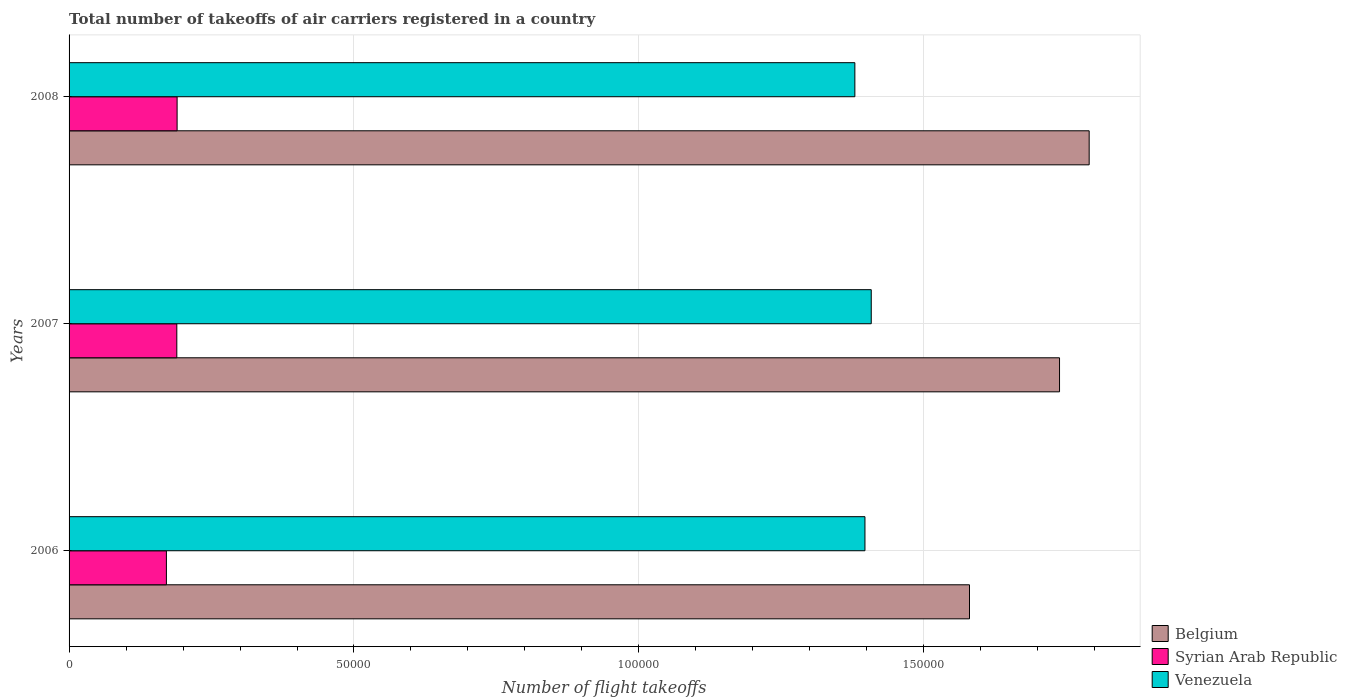How many different coloured bars are there?
Make the answer very short. 3. How many groups of bars are there?
Your answer should be compact. 3. Are the number of bars on each tick of the Y-axis equal?
Provide a succinct answer. Yes. What is the total number of flight takeoffs in Venezuela in 2006?
Offer a terse response. 1.40e+05. Across all years, what is the maximum total number of flight takeoffs in Belgium?
Your response must be concise. 1.79e+05. Across all years, what is the minimum total number of flight takeoffs in Syrian Arab Republic?
Ensure brevity in your answer.  1.71e+04. In which year was the total number of flight takeoffs in Belgium maximum?
Your answer should be very brief. 2008. In which year was the total number of flight takeoffs in Belgium minimum?
Make the answer very short. 2006. What is the total total number of flight takeoffs in Syrian Arab Republic in the graph?
Your answer should be compact. 5.50e+04. What is the difference between the total number of flight takeoffs in Venezuela in 2006 and that in 2008?
Your answer should be very brief. 1771. What is the difference between the total number of flight takeoffs in Belgium in 2006 and the total number of flight takeoffs in Syrian Arab Republic in 2007?
Give a very brief answer. 1.39e+05. What is the average total number of flight takeoffs in Syrian Arab Republic per year?
Give a very brief answer. 1.83e+04. In the year 2006, what is the difference between the total number of flight takeoffs in Belgium and total number of flight takeoffs in Venezuela?
Give a very brief answer. 1.83e+04. In how many years, is the total number of flight takeoffs in Belgium greater than 50000 ?
Offer a terse response. 3. What is the ratio of the total number of flight takeoffs in Syrian Arab Republic in 2007 to that in 2008?
Your answer should be compact. 1. Is the total number of flight takeoffs in Venezuela in 2006 less than that in 2008?
Provide a short and direct response. No. Is the difference between the total number of flight takeoffs in Belgium in 2007 and 2008 greater than the difference between the total number of flight takeoffs in Venezuela in 2007 and 2008?
Ensure brevity in your answer.  No. What is the difference between the highest and the lowest total number of flight takeoffs in Belgium?
Keep it short and to the point. 2.10e+04. In how many years, is the total number of flight takeoffs in Belgium greater than the average total number of flight takeoffs in Belgium taken over all years?
Offer a very short reply. 2. Is the sum of the total number of flight takeoffs in Syrian Arab Republic in 2006 and 2007 greater than the maximum total number of flight takeoffs in Belgium across all years?
Make the answer very short. No. What does the 1st bar from the top in 2006 represents?
Provide a short and direct response. Venezuela. What does the 3rd bar from the bottom in 2007 represents?
Keep it short and to the point. Venezuela. How many bars are there?
Your answer should be very brief. 9. Are all the bars in the graph horizontal?
Provide a short and direct response. Yes. How many years are there in the graph?
Your answer should be very brief. 3. What is the difference between two consecutive major ticks on the X-axis?
Keep it short and to the point. 5.00e+04. Does the graph contain any zero values?
Ensure brevity in your answer.  No. Where does the legend appear in the graph?
Your response must be concise. Bottom right. How many legend labels are there?
Your answer should be very brief. 3. How are the legend labels stacked?
Your answer should be very brief. Vertical. What is the title of the graph?
Your response must be concise. Total number of takeoffs of air carriers registered in a country. Does "Maldives" appear as one of the legend labels in the graph?
Offer a terse response. No. What is the label or title of the X-axis?
Offer a very short reply. Number of flight takeoffs. What is the label or title of the Y-axis?
Make the answer very short. Years. What is the Number of flight takeoffs in Belgium in 2006?
Provide a succinct answer. 1.58e+05. What is the Number of flight takeoffs of Syrian Arab Republic in 2006?
Your answer should be very brief. 1.71e+04. What is the Number of flight takeoffs of Venezuela in 2006?
Your response must be concise. 1.40e+05. What is the Number of flight takeoffs in Belgium in 2007?
Your response must be concise. 1.74e+05. What is the Number of flight takeoffs in Syrian Arab Republic in 2007?
Provide a succinct answer. 1.89e+04. What is the Number of flight takeoffs of Venezuela in 2007?
Keep it short and to the point. 1.41e+05. What is the Number of flight takeoffs in Belgium in 2008?
Keep it short and to the point. 1.79e+05. What is the Number of flight takeoffs in Syrian Arab Republic in 2008?
Make the answer very short. 1.90e+04. What is the Number of flight takeoffs of Venezuela in 2008?
Make the answer very short. 1.38e+05. Across all years, what is the maximum Number of flight takeoffs of Belgium?
Offer a terse response. 1.79e+05. Across all years, what is the maximum Number of flight takeoffs in Syrian Arab Republic?
Offer a terse response. 1.90e+04. Across all years, what is the maximum Number of flight takeoffs in Venezuela?
Your response must be concise. 1.41e+05. Across all years, what is the minimum Number of flight takeoffs in Belgium?
Your answer should be compact. 1.58e+05. Across all years, what is the minimum Number of flight takeoffs in Syrian Arab Republic?
Your answer should be compact. 1.71e+04. Across all years, what is the minimum Number of flight takeoffs in Venezuela?
Give a very brief answer. 1.38e+05. What is the total Number of flight takeoffs of Belgium in the graph?
Provide a succinct answer. 5.11e+05. What is the total Number of flight takeoffs in Syrian Arab Republic in the graph?
Your answer should be very brief. 5.50e+04. What is the total Number of flight takeoffs in Venezuela in the graph?
Ensure brevity in your answer.  4.18e+05. What is the difference between the Number of flight takeoffs in Belgium in 2006 and that in 2007?
Your answer should be compact. -1.58e+04. What is the difference between the Number of flight takeoffs of Syrian Arab Republic in 2006 and that in 2007?
Make the answer very short. -1827. What is the difference between the Number of flight takeoffs in Venezuela in 2006 and that in 2007?
Make the answer very short. -1103. What is the difference between the Number of flight takeoffs in Belgium in 2006 and that in 2008?
Ensure brevity in your answer.  -2.10e+04. What is the difference between the Number of flight takeoffs of Syrian Arab Republic in 2006 and that in 2008?
Keep it short and to the point. -1878. What is the difference between the Number of flight takeoffs in Venezuela in 2006 and that in 2008?
Make the answer very short. 1771. What is the difference between the Number of flight takeoffs in Belgium in 2007 and that in 2008?
Offer a very short reply. -5201. What is the difference between the Number of flight takeoffs in Syrian Arab Republic in 2007 and that in 2008?
Keep it short and to the point. -51. What is the difference between the Number of flight takeoffs in Venezuela in 2007 and that in 2008?
Give a very brief answer. 2874. What is the difference between the Number of flight takeoffs in Belgium in 2006 and the Number of flight takeoffs in Syrian Arab Republic in 2007?
Offer a very short reply. 1.39e+05. What is the difference between the Number of flight takeoffs of Belgium in 2006 and the Number of flight takeoffs of Venezuela in 2007?
Provide a short and direct response. 1.72e+04. What is the difference between the Number of flight takeoffs of Syrian Arab Republic in 2006 and the Number of flight takeoffs of Venezuela in 2007?
Provide a short and direct response. -1.24e+05. What is the difference between the Number of flight takeoffs in Belgium in 2006 and the Number of flight takeoffs in Syrian Arab Republic in 2008?
Provide a succinct answer. 1.39e+05. What is the difference between the Number of flight takeoffs of Belgium in 2006 and the Number of flight takeoffs of Venezuela in 2008?
Your answer should be compact. 2.01e+04. What is the difference between the Number of flight takeoffs of Syrian Arab Republic in 2006 and the Number of flight takeoffs of Venezuela in 2008?
Keep it short and to the point. -1.21e+05. What is the difference between the Number of flight takeoffs in Belgium in 2007 and the Number of flight takeoffs in Syrian Arab Republic in 2008?
Ensure brevity in your answer.  1.55e+05. What is the difference between the Number of flight takeoffs in Belgium in 2007 and the Number of flight takeoffs in Venezuela in 2008?
Ensure brevity in your answer.  3.59e+04. What is the difference between the Number of flight takeoffs of Syrian Arab Republic in 2007 and the Number of flight takeoffs of Venezuela in 2008?
Offer a terse response. -1.19e+05. What is the average Number of flight takeoffs of Belgium per year?
Your response must be concise. 1.70e+05. What is the average Number of flight takeoffs of Syrian Arab Republic per year?
Provide a succinct answer. 1.83e+04. What is the average Number of flight takeoffs in Venezuela per year?
Your answer should be very brief. 1.39e+05. In the year 2006, what is the difference between the Number of flight takeoffs of Belgium and Number of flight takeoffs of Syrian Arab Republic?
Offer a very short reply. 1.41e+05. In the year 2006, what is the difference between the Number of flight takeoffs in Belgium and Number of flight takeoffs in Venezuela?
Provide a succinct answer. 1.83e+04. In the year 2006, what is the difference between the Number of flight takeoffs of Syrian Arab Republic and Number of flight takeoffs of Venezuela?
Make the answer very short. -1.23e+05. In the year 2007, what is the difference between the Number of flight takeoffs in Belgium and Number of flight takeoffs in Syrian Arab Republic?
Provide a short and direct response. 1.55e+05. In the year 2007, what is the difference between the Number of flight takeoffs in Belgium and Number of flight takeoffs in Venezuela?
Your response must be concise. 3.30e+04. In the year 2007, what is the difference between the Number of flight takeoffs in Syrian Arab Republic and Number of flight takeoffs in Venezuela?
Make the answer very short. -1.22e+05. In the year 2008, what is the difference between the Number of flight takeoffs in Belgium and Number of flight takeoffs in Syrian Arab Republic?
Your answer should be very brief. 1.60e+05. In the year 2008, what is the difference between the Number of flight takeoffs in Belgium and Number of flight takeoffs in Venezuela?
Ensure brevity in your answer.  4.11e+04. In the year 2008, what is the difference between the Number of flight takeoffs in Syrian Arab Republic and Number of flight takeoffs in Venezuela?
Provide a succinct answer. -1.19e+05. What is the ratio of the Number of flight takeoffs in Syrian Arab Republic in 2006 to that in 2007?
Your answer should be compact. 0.9. What is the ratio of the Number of flight takeoffs in Belgium in 2006 to that in 2008?
Provide a succinct answer. 0.88. What is the ratio of the Number of flight takeoffs of Syrian Arab Republic in 2006 to that in 2008?
Offer a terse response. 0.9. What is the ratio of the Number of flight takeoffs in Venezuela in 2006 to that in 2008?
Provide a succinct answer. 1.01. What is the ratio of the Number of flight takeoffs in Belgium in 2007 to that in 2008?
Your answer should be very brief. 0.97. What is the ratio of the Number of flight takeoffs in Syrian Arab Republic in 2007 to that in 2008?
Your answer should be compact. 1. What is the ratio of the Number of flight takeoffs in Venezuela in 2007 to that in 2008?
Make the answer very short. 1.02. What is the difference between the highest and the second highest Number of flight takeoffs in Belgium?
Provide a short and direct response. 5201. What is the difference between the highest and the second highest Number of flight takeoffs in Venezuela?
Keep it short and to the point. 1103. What is the difference between the highest and the lowest Number of flight takeoffs in Belgium?
Make the answer very short. 2.10e+04. What is the difference between the highest and the lowest Number of flight takeoffs of Syrian Arab Republic?
Ensure brevity in your answer.  1878. What is the difference between the highest and the lowest Number of flight takeoffs of Venezuela?
Provide a short and direct response. 2874. 